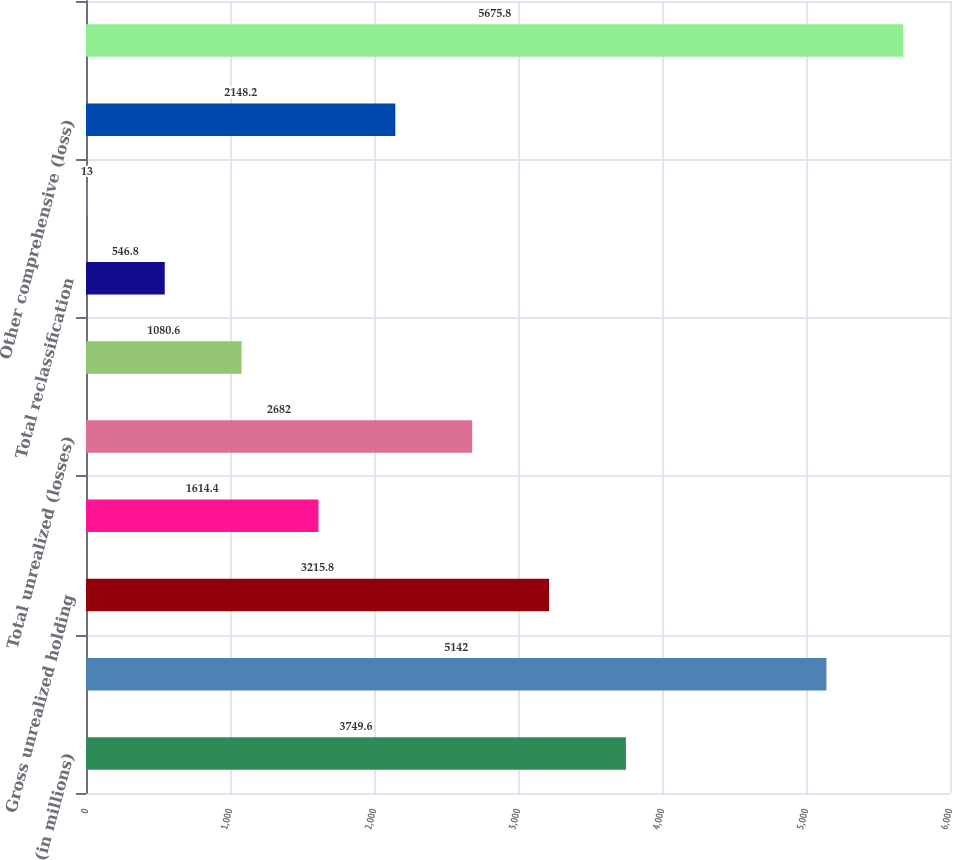<chart> <loc_0><loc_0><loc_500><loc_500><bar_chart><fcel>(in millions)<fcel>Net earnings<fcel>Gross unrealized holding<fcel>Income tax effect<fcel>Total unrealized (losses)<fcel>Gross reclassification<fcel>Total reclassification<fcel>Total foreign currency<fcel>Other comprehensive (loss)<fcel>Comprehensive income<nl><fcel>3749.6<fcel>5142<fcel>3215.8<fcel>1614.4<fcel>2682<fcel>1080.6<fcel>546.8<fcel>13<fcel>2148.2<fcel>5675.8<nl></chart> 